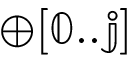Convert formula to latex. <formula><loc_0><loc_0><loc_500><loc_500>\mathbb { \oplus [ 0 . . j ] }</formula> 